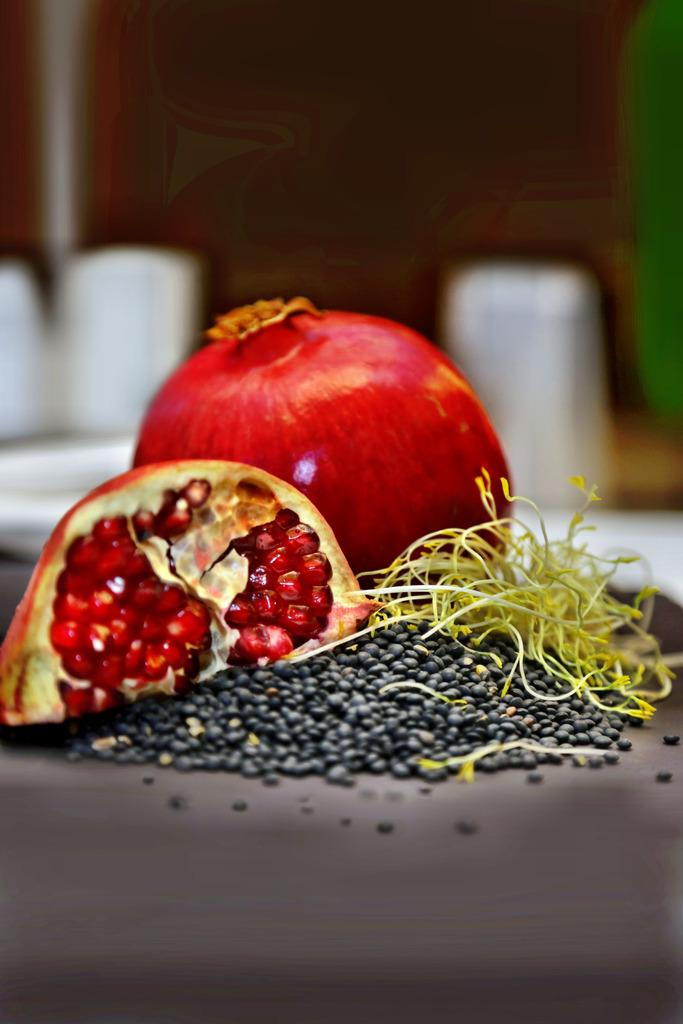What type of fruit is present in the image? There are two pomegranates in the image. What color are the grains inside the pomegranates? The grains inside the pomegranates are black in color. What type of mine is visible in the image? There is no mine present in the image; it features two pomegranates and black grains. Is there a scarecrow standing near the pomegranates in the image? There is no scarecrow present in the image. 